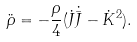Convert formula to latex. <formula><loc_0><loc_0><loc_500><loc_500>\ddot { \rho } = - \frac { \rho } { 4 } ( \dot { J } \dot { \bar { J } } - \dot { K } ^ { 2 } ) .</formula> 